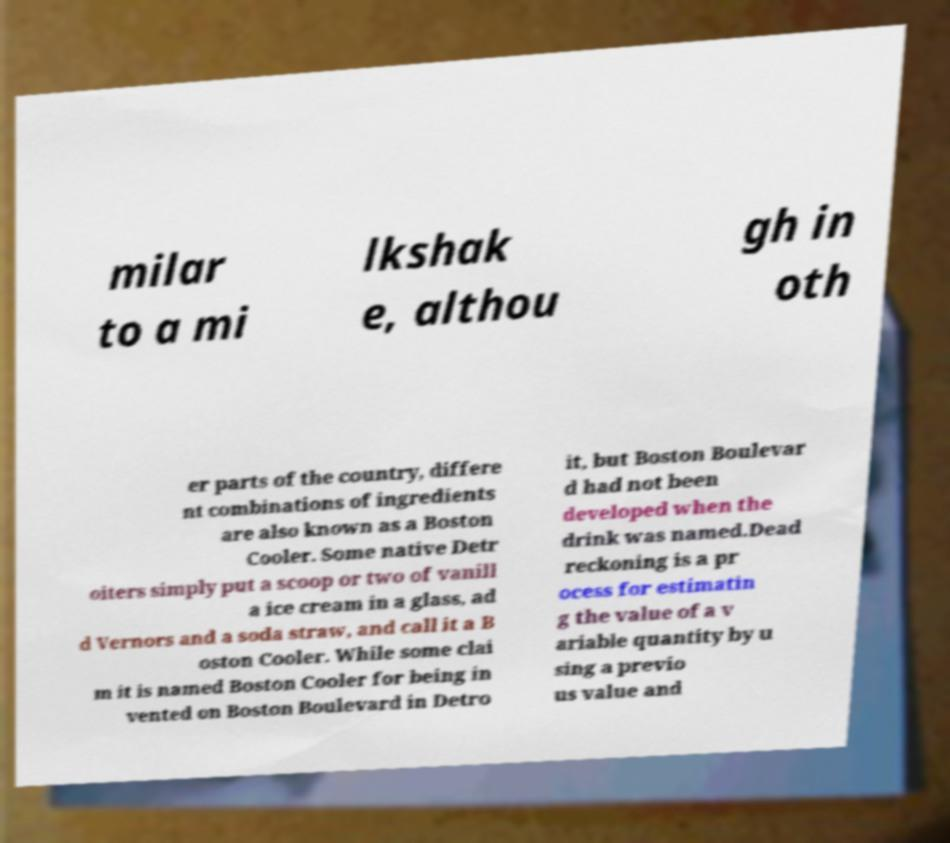For documentation purposes, I need the text within this image transcribed. Could you provide that? milar to a mi lkshak e, althou gh in oth er parts of the country, differe nt combinations of ingredients are also known as a Boston Cooler. Some native Detr oiters simply put a scoop or two of vanill a ice cream in a glass, ad d Vernors and a soda straw, and call it a B oston Cooler. While some clai m it is named Boston Cooler for being in vented on Boston Boulevard in Detro it, but Boston Boulevar d had not been developed when the drink was named.Dead reckoning is a pr ocess for estimatin g the value of a v ariable quantity by u sing a previo us value and 